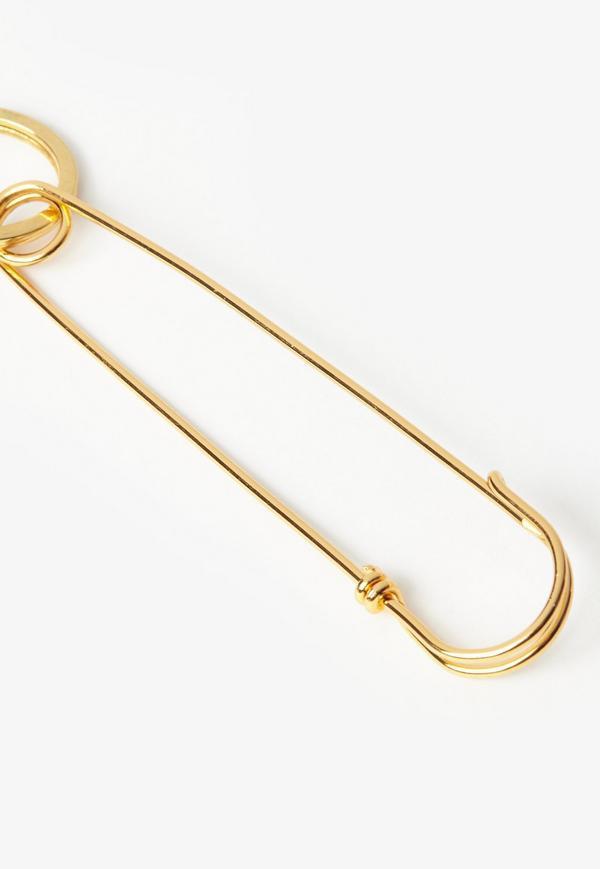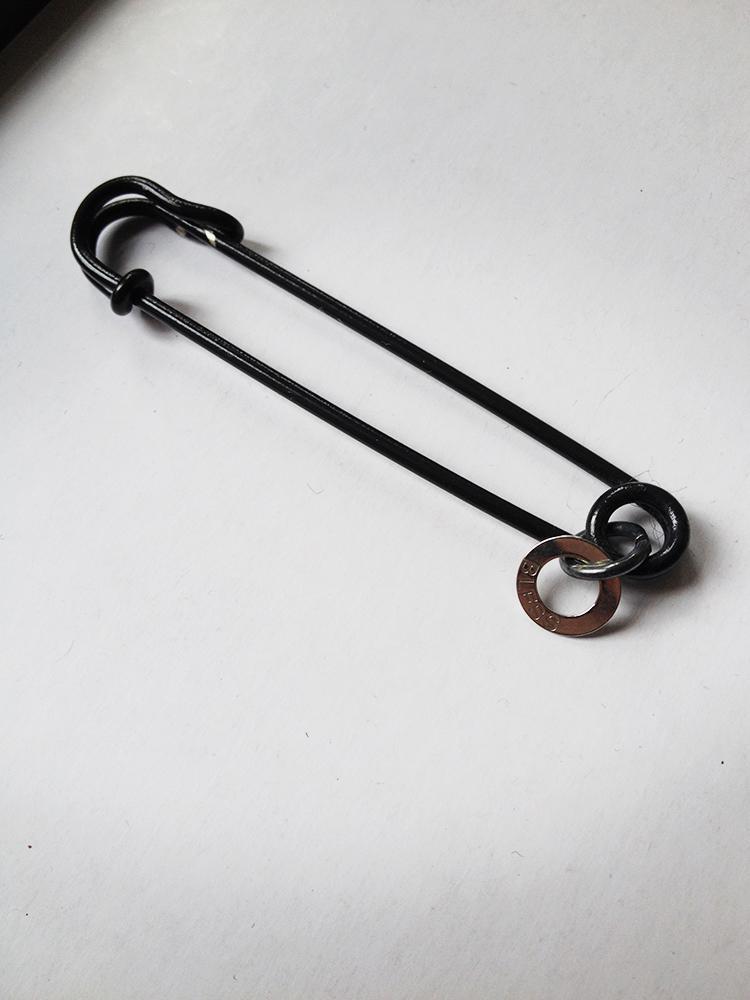The first image is the image on the left, the second image is the image on the right. Examine the images to the left and right. Is the description "One image contains exactly two safety pins." accurate? Answer yes or no. No. 